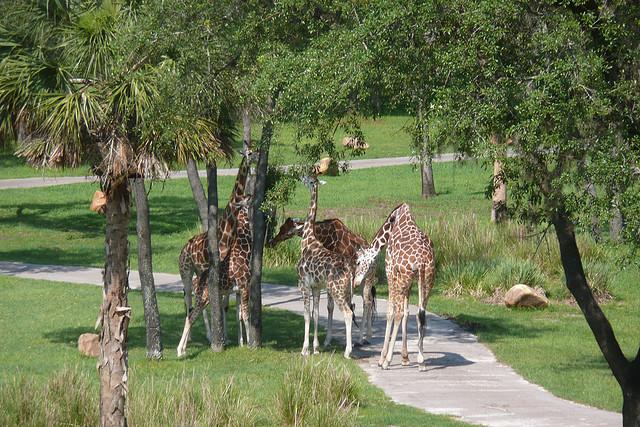What animal is shown?
Quick response, please. Giraffe. How many animals are in this picture?
Give a very brief answer. 5. What is the giraffe walking between?
Write a very short answer. Trees. What kind of trees are shown?
Answer briefly. Palm. How many trees are visible?
Short answer required. 10. How is this path paved?
Quick response, please. Cement. Do the giraffe have water available?
Keep it brief. No. Is there an enclosure behind them?
Concise answer only. No. How many giraffe are standing side by side?
Write a very short answer. 4. Is the giraffe stuck?
Concise answer only. No. Are the smaller animals baby giraffes?
Keep it brief. Yes. 